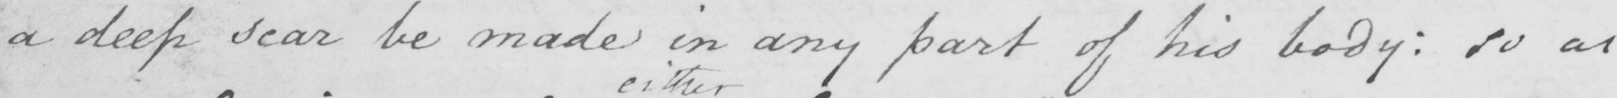What text is written in this handwritten line? a deep scar be made in any part of his body: so as 